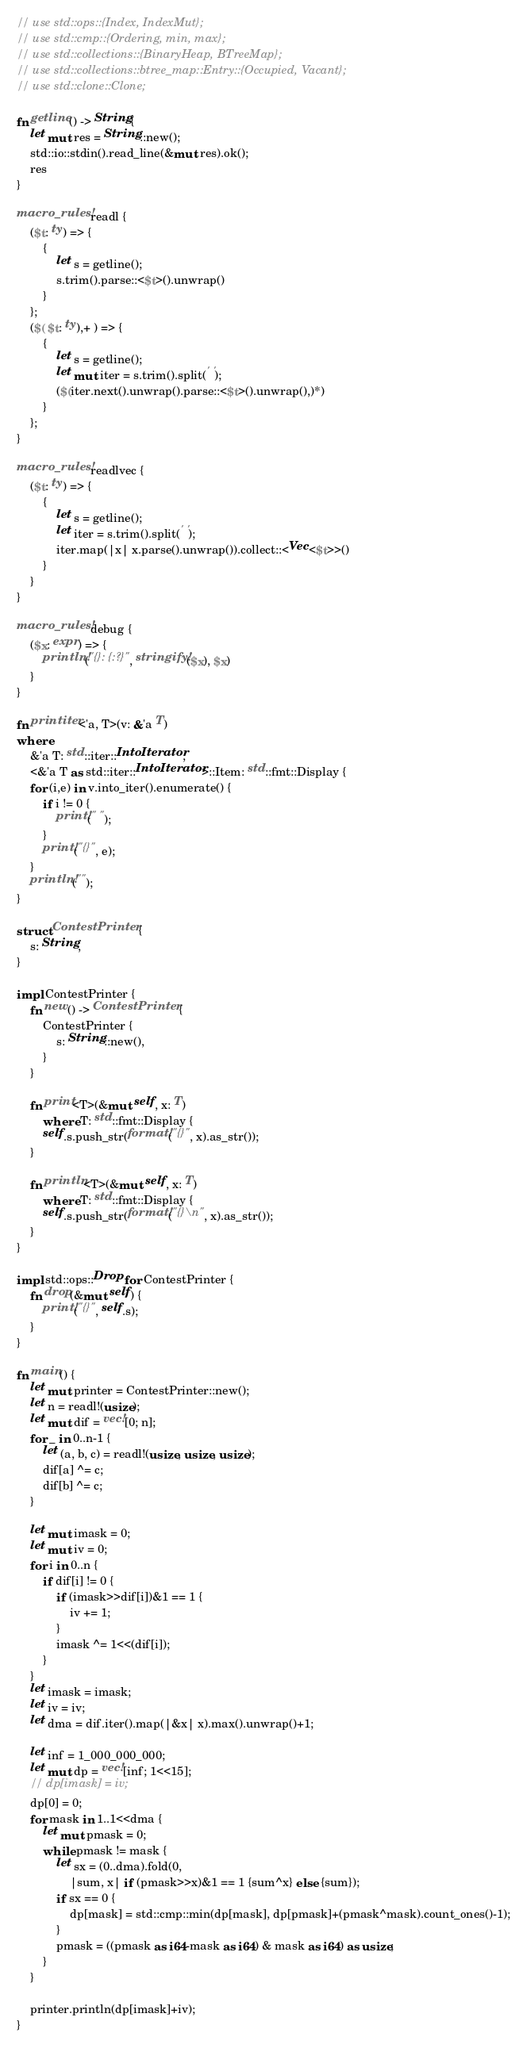Convert code to text. <code><loc_0><loc_0><loc_500><loc_500><_Rust_>// use std::ops::{Index, IndexMut};
// use std::cmp::{Ordering, min, max};
// use std::collections::{BinaryHeap, BTreeMap};
// use std::collections::btree_map::Entry::{Occupied, Vacant};
// use std::clone::Clone;

fn getline() -> String{
    let mut res = String::new();
    std::io::stdin().read_line(&mut res).ok();
    res
}

macro_rules! readl {
    ($t: ty) => {
        {
            let s = getline();
            s.trim().parse::<$t>().unwrap()
        }
    };
    ($( $t: ty),+ ) => {
        {
            let s = getline();
            let mut iter = s.trim().split(' ');
            ($(iter.next().unwrap().parse::<$t>().unwrap(),)*) 
        }
    };
}

macro_rules! readlvec {
    ($t: ty) => {
        {
            let s = getline();
            let iter = s.trim().split(' ');
            iter.map(|x| x.parse().unwrap()).collect::<Vec<$t>>()
        }
    }
}

macro_rules! debug {
    ($x: expr) => {
        println!("{}: {:?}", stringify!($x), $x)
    }
}

fn printiter<'a, T>(v: &'a T)
where
    &'a T: std::iter::IntoIterator, 
    <&'a T as std::iter::IntoIterator>::Item: std::fmt::Display {
    for (i,e) in v.into_iter().enumerate() {
        if i != 0 {
            print!(" ");
        }
        print!("{}", e);
    }
    println!("");
}

struct ContestPrinter {
    s: String,
}

impl ContestPrinter {
    fn new() -> ContestPrinter {
        ContestPrinter {
            s: String::new(),
        }
    }

    fn print<T>(&mut self, x: T)
        where T: std::fmt::Display {
        self.s.push_str(format!("{}", x).as_str());
    }

    fn println<T>(&mut self, x: T)
        where T: std::fmt::Display {
        self.s.push_str(format!("{}\n", x).as_str());
    }
}

impl std::ops::Drop for ContestPrinter {
    fn drop(&mut self) {
        print!("{}", self.s);
    }
}

fn main() {
    let mut printer = ContestPrinter::new();
    let n = readl!(usize);
    let mut dif = vec![0; n];
    for _ in 0..n-1 {
        let (a, b, c) = readl!(usize, usize, usize);
        dif[a] ^= c;
        dif[b] ^= c;
    }

    let mut imask = 0;
    let mut iv = 0;
    for i in 0..n {
        if dif[i] != 0 {
            if (imask>>dif[i])&1 == 1 {
                iv += 1;
            }
            imask ^= 1<<(dif[i]);
        }
    }
    let imask = imask;
    let iv = iv;
    let dma = dif.iter().map(|&x| x).max().unwrap()+1;
    
    let inf = 1_000_000_000;
    let mut dp = vec![inf; 1<<15];
    // dp[imask] = iv;
    dp[0] = 0;
    for mask in 1..1<<dma {
        let mut pmask = 0;
        while pmask != mask {
            let sx = (0..dma).fold(0, 
                |sum, x| if (pmask>>x)&1 == 1 {sum^x} else {sum});
            if sx == 0 {
                dp[mask] = std::cmp::min(dp[mask], dp[pmask]+(pmask^mask).count_ones()-1);
            }
            pmask = ((pmask as i64-mask as i64) & mask as i64) as usize;
        }
    }
    
    printer.println(dp[imask]+iv);
}

</code> 